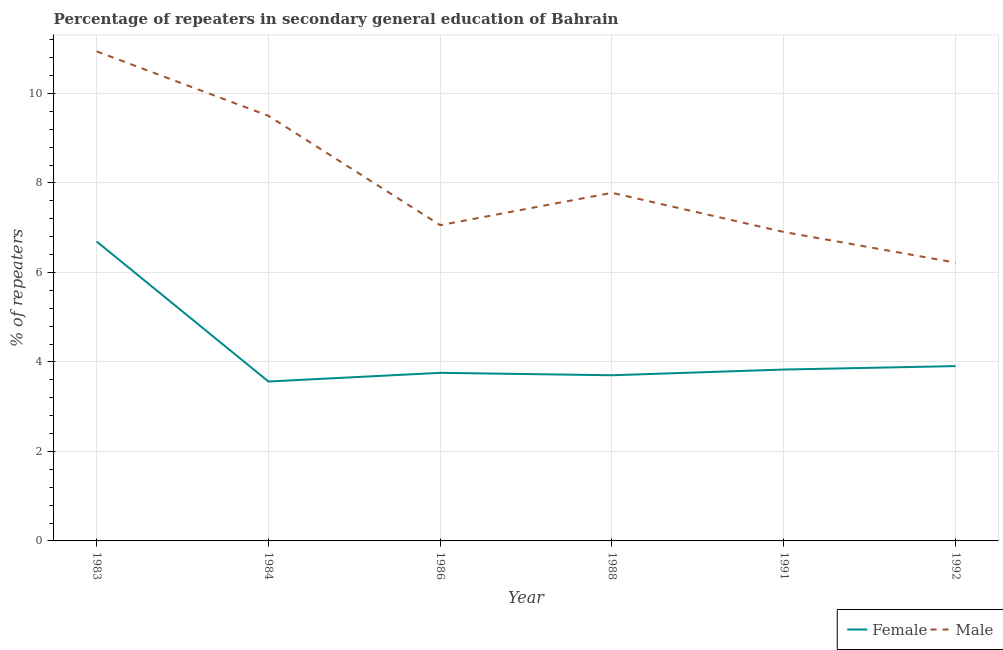Is the number of lines equal to the number of legend labels?
Provide a short and direct response. Yes. What is the percentage of male repeaters in 1992?
Give a very brief answer. 6.22. Across all years, what is the maximum percentage of female repeaters?
Provide a short and direct response. 6.69. Across all years, what is the minimum percentage of female repeaters?
Provide a short and direct response. 3.56. What is the total percentage of male repeaters in the graph?
Give a very brief answer. 48.4. What is the difference between the percentage of female repeaters in 1984 and that in 1986?
Provide a succinct answer. -0.19. What is the difference between the percentage of male repeaters in 1988 and the percentage of female repeaters in 1992?
Provide a succinct answer. 3.87. What is the average percentage of female repeaters per year?
Offer a very short reply. 4.24. In the year 1984, what is the difference between the percentage of male repeaters and percentage of female repeaters?
Offer a terse response. 5.94. What is the ratio of the percentage of male repeaters in 1991 to that in 1992?
Your answer should be compact. 1.11. Is the percentage of female repeaters in 1986 less than that in 1991?
Offer a very short reply. Yes. What is the difference between the highest and the second highest percentage of male repeaters?
Offer a terse response. 1.44. What is the difference between the highest and the lowest percentage of female repeaters?
Your answer should be compact. 3.13. In how many years, is the percentage of female repeaters greater than the average percentage of female repeaters taken over all years?
Your answer should be very brief. 1. Does the percentage of male repeaters monotonically increase over the years?
Your answer should be compact. No. How many lines are there?
Offer a very short reply. 2. Are the values on the major ticks of Y-axis written in scientific E-notation?
Ensure brevity in your answer.  No. Where does the legend appear in the graph?
Offer a terse response. Bottom right. What is the title of the graph?
Your answer should be compact. Percentage of repeaters in secondary general education of Bahrain. Does "Private consumption" appear as one of the legend labels in the graph?
Make the answer very short. No. What is the label or title of the Y-axis?
Provide a short and direct response. % of repeaters. What is the % of repeaters of Female in 1983?
Give a very brief answer. 6.69. What is the % of repeaters in Male in 1983?
Make the answer very short. 10.94. What is the % of repeaters of Female in 1984?
Your response must be concise. 3.56. What is the % of repeaters of Male in 1984?
Make the answer very short. 9.5. What is the % of repeaters in Female in 1986?
Ensure brevity in your answer.  3.76. What is the % of repeaters of Male in 1986?
Make the answer very short. 7.06. What is the % of repeaters in Female in 1988?
Provide a short and direct response. 3.7. What is the % of repeaters in Male in 1988?
Your response must be concise. 7.78. What is the % of repeaters of Female in 1991?
Keep it short and to the point. 3.83. What is the % of repeaters in Male in 1991?
Offer a very short reply. 6.9. What is the % of repeaters of Female in 1992?
Ensure brevity in your answer.  3.91. What is the % of repeaters in Male in 1992?
Give a very brief answer. 6.22. Across all years, what is the maximum % of repeaters of Female?
Your answer should be compact. 6.69. Across all years, what is the maximum % of repeaters of Male?
Provide a succinct answer. 10.94. Across all years, what is the minimum % of repeaters in Female?
Give a very brief answer. 3.56. Across all years, what is the minimum % of repeaters in Male?
Your answer should be very brief. 6.22. What is the total % of repeaters of Female in the graph?
Keep it short and to the point. 25.45. What is the total % of repeaters in Male in the graph?
Offer a very short reply. 48.4. What is the difference between the % of repeaters in Female in 1983 and that in 1984?
Offer a terse response. 3.13. What is the difference between the % of repeaters of Male in 1983 and that in 1984?
Offer a terse response. 1.44. What is the difference between the % of repeaters of Female in 1983 and that in 1986?
Give a very brief answer. 2.93. What is the difference between the % of repeaters in Male in 1983 and that in 1986?
Offer a terse response. 3.88. What is the difference between the % of repeaters of Female in 1983 and that in 1988?
Provide a short and direct response. 2.99. What is the difference between the % of repeaters in Male in 1983 and that in 1988?
Keep it short and to the point. 3.16. What is the difference between the % of repeaters of Female in 1983 and that in 1991?
Your response must be concise. 2.86. What is the difference between the % of repeaters in Male in 1983 and that in 1991?
Provide a short and direct response. 4.04. What is the difference between the % of repeaters in Female in 1983 and that in 1992?
Keep it short and to the point. 2.78. What is the difference between the % of repeaters in Male in 1983 and that in 1992?
Ensure brevity in your answer.  4.72. What is the difference between the % of repeaters in Female in 1984 and that in 1986?
Offer a terse response. -0.19. What is the difference between the % of repeaters in Male in 1984 and that in 1986?
Provide a succinct answer. 2.44. What is the difference between the % of repeaters of Female in 1984 and that in 1988?
Give a very brief answer. -0.14. What is the difference between the % of repeaters in Male in 1984 and that in 1988?
Your response must be concise. 1.72. What is the difference between the % of repeaters in Female in 1984 and that in 1991?
Ensure brevity in your answer.  -0.27. What is the difference between the % of repeaters in Male in 1984 and that in 1991?
Offer a terse response. 2.6. What is the difference between the % of repeaters of Female in 1984 and that in 1992?
Offer a very short reply. -0.34. What is the difference between the % of repeaters of Male in 1984 and that in 1992?
Keep it short and to the point. 3.28. What is the difference between the % of repeaters of Female in 1986 and that in 1988?
Offer a very short reply. 0.05. What is the difference between the % of repeaters of Male in 1986 and that in 1988?
Your answer should be compact. -0.72. What is the difference between the % of repeaters of Female in 1986 and that in 1991?
Your answer should be very brief. -0.07. What is the difference between the % of repeaters in Male in 1986 and that in 1991?
Provide a short and direct response. 0.15. What is the difference between the % of repeaters in Female in 1986 and that in 1992?
Keep it short and to the point. -0.15. What is the difference between the % of repeaters in Male in 1986 and that in 1992?
Ensure brevity in your answer.  0.84. What is the difference between the % of repeaters of Female in 1988 and that in 1991?
Make the answer very short. -0.13. What is the difference between the % of repeaters of Male in 1988 and that in 1991?
Your answer should be compact. 0.87. What is the difference between the % of repeaters of Female in 1988 and that in 1992?
Offer a very short reply. -0.2. What is the difference between the % of repeaters in Male in 1988 and that in 1992?
Your answer should be very brief. 1.56. What is the difference between the % of repeaters in Female in 1991 and that in 1992?
Provide a succinct answer. -0.08. What is the difference between the % of repeaters of Male in 1991 and that in 1992?
Ensure brevity in your answer.  0.68. What is the difference between the % of repeaters of Female in 1983 and the % of repeaters of Male in 1984?
Ensure brevity in your answer.  -2.81. What is the difference between the % of repeaters in Female in 1983 and the % of repeaters in Male in 1986?
Ensure brevity in your answer.  -0.37. What is the difference between the % of repeaters of Female in 1983 and the % of repeaters of Male in 1988?
Keep it short and to the point. -1.09. What is the difference between the % of repeaters in Female in 1983 and the % of repeaters in Male in 1991?
Provide a short and direct response. -0.21. What is the difference between the % of repeaters in Female in 1983 and the % of repeaters in Male in 1992?
Make the answer very short. 0.47. What is the difference between the % of repeaters in Female in 1984 and the % of repeaters in Male in 1986?
Make the answer very short. -3.49. What is the difference between the % of repeaters in Female in 1984 and the % of repeaters in Male in 1988?
Keep it short and to the point. -4.22. What is the difference between the % of repeaters of Female in 1984 and the % of repeaters of Male in 1991?
Provide a short and direct response. -3.34. What is the difference between the % of repeaters of Female in 1984 and the % of repeaters of Male in 1992?
Provide a short and direct response. -2.66. What is the difference between the % of repeaters in Female in 1986 and the % of repeaters in Male in 1988?
Offer a terse response. -4.02. What is the difference between the % of repeaters in Female in 1986 and the % of repeaters in Male in 1991?
Provide a short and direct response. -3.15. What is the difference between the % of repeaters in Female in 1986 and the % of repeaters in Male in 1992?
Keep it short and to the point. -2.46. What is the difference between the % of repeaters of Female in 1988 and the % of repeaters of Male in 1991?
Make the answer very short. -3.2. What is the difference between the % of repeaters in Female in 1988 and the % of repeaters in Male in 1992?
Your answer should be compact. -2.52. What is the difference between the % of repeaters in Female in 1991 and the % of repeaters in Male in 1992?
Provide a short and direct response. -2.39. What is the average % of repeaters in Female per year?
Keep it short and to the point. 4.24. What is the average % of repeaters in Male per year?
Your answer should be very brief. 8.07. In the year 1983, what is the difference between the % of repeaters of Female and % of repeaters of Male?
Offer a very short reply. -4.25. In the year 1984, what is the difference between the % of repeaters of Female and % of repeaters of Male?
Ensure brevity in your answer.  -5.94. In the year 1986, what is the difference between the % of repeaters in Female and % of repeaters in Male?
Provide a short and direct response. -3.3. In the year 1988, what is the difference between the % of repeaters of Female and % of repeaters of Male?
Provide a short and direct response. -4.08. In the year 1991, what is the difference between the % of repeaters of Female and % of repeaters of Male?
Offer a very short reply. -3.07. In the year 1992, what is the difference between the % of repeaters of Female and % of repeaters of Male?
Your answer should be very brief. -2.31. What is the ratio of the % of repeaters in Female in 1983 to that in 1984?
Provide a short and direct response. 1.88. What is the ratio of the % of repeaters of Male in 1983 to that in 1984?
Your response must be concise. 1.15. What is the ratio of the % of repeaters of Female in 1983 to that in 1986?
Provide a succinct answer. 1.78. What is the ratio of the % of repeaters in Male in 1983 to that in 1986?
Ensure brevity in your answer.  1.55. What is the ratio of the % of repeaters in Female in 1983 to that in 1988?
Offer a terse response. 1.81. What is the ratio of the % of repeaters of Male in 1983 to that in 1988?
Provide a succinct answer. 1.41. What is the ratio of the % of repeaters in Female in 1983 to that in 1991?
Provide a short and direct response. 1.75. What is the ratio of the % of repeaters in Male in 1983 to that in 1991?
Keep it short and to the point. 1.58. What is the ratio of the % of repeaters of Female in 1983 to that in 1992?
Give a very brief answer. 1.71. What is the ratio of the % of repeaters in Male in 1983 to that in 1992?
Provide a succinct answer. 1.76. What is the ratio of the % of repeaters of Female in 1984 to that in 1986?
Provide a succinct answer. 0.95. What is the ratio of the % of repeaters of Male in 1984 to that in 1986?
Keep it short and to the point. 1.35. What is the ratio of the % of repeaters in Female in 1984 to that in 1988?
Your answer should be very brief. 0.96. What is the ratio of the % of repeaters in Male in 1984 to that in 1988?
Your answer should be compact. 1.22. What is the ratio of the % of repeaters of Female in 1984 to that in 1991?
Your answer should be compact. 0.93. What is the ratio of the % of repeaters of Male in 1984 to that in 1991?
Offer a terse response. 1.38. What is the ratio of the % of repeaters of Female in 1984 to that in 1992?
Your response must be concise. 0.91. What is the ratio of the % of repeaters in Male in 1984 to that in 1992?
Ensure brevity in your answer.  1.53. What is the ratio of the % of repeaters of Female in 1986 to that in 1988?
Keep it short and to the point. 1.01. What is the ratio of the % of repeaters of Male in 1986 to that in 1988?
Keep it short and to the point. 0.91. What is the ratio of the % of repeaters of Female in 1986 to that in 1991?
Give a very brief answer. 0.98. What is the ratio of the % of repeaters in Male in 1986 to that in 1991?
Ensure brevity in your answer.  1.02. What is the ratio of the % of repeaters in Female in 1986 to that in 1992?
Ensure brevity in your answer.  0.96. What is the ratio of the % of repeaters of Male in 1986 to that in 1992?
Your response must be concise. 1.13. What is the ratio of the % of repeaters in Female in 1988 to that in 1991?
Your response must be concise. 0.97. What is the ratio of the % of repeaters of Male in 1988 to that in 1991?
Provide a succinct answer. 1.13. What is the ratio of the % of repeaters in Female in 1988 to that in 1992?
Offer a terse response. 0.95. What is the ratio of the % of repeaters in Male in 1988 to that in 1992?
Give a very brief answer. 1.25. What is the ratio of the % of repeaters in Female in 1991 to that in 1992?
Offer a terse response. 0.98. What is the ratio of the % of repeaters of Male in 1991 to that in 1992?
Keep it short and to the point. 1.11. What is the difference between the highest and the second highest % of repeaters in Female?
Provide a succinct answer. 2.78. What is the difference between the highest and the second highest % of repeaters in Male?
Provide a short and direct response. 1.44. What is the difference between the highest and the lowest % of repeaters in Female?
Your answer should be very brief. 3.13. What is the difference between the highest and the lowest % of repeaters in Male?
Give a very brief answer. 4.72. 